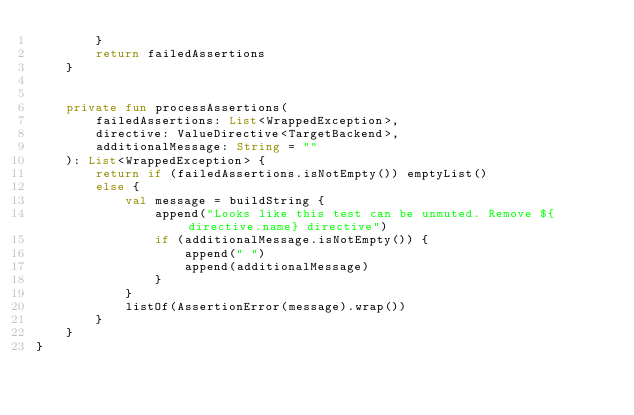Convert code to text. <code><loc_0><loc_0><loc_500><loc_500><_Kotlin_>        }
        return failedAssertions
    }


    private fun processAssertions(
        failedAssertions: List<WrappedException>,
        directive: ValueDirective<TargetBackend>,
        additionalMessage: String = ""
    ): List<WrappedException> {
        return if (failedAssertions.isNotEmpty()) emptyList()
        else {
            val message = buildString {
                append("Looks like this test can be unmuted. Remove ${directive.name} directive")
                if (additionalMessage.isNotEmpty()) {
                    append(" ")
                    append(additionalMessage)
                }
            }
            listOf(AssertionError(message).wrap())
        }
    }
}
</code> 